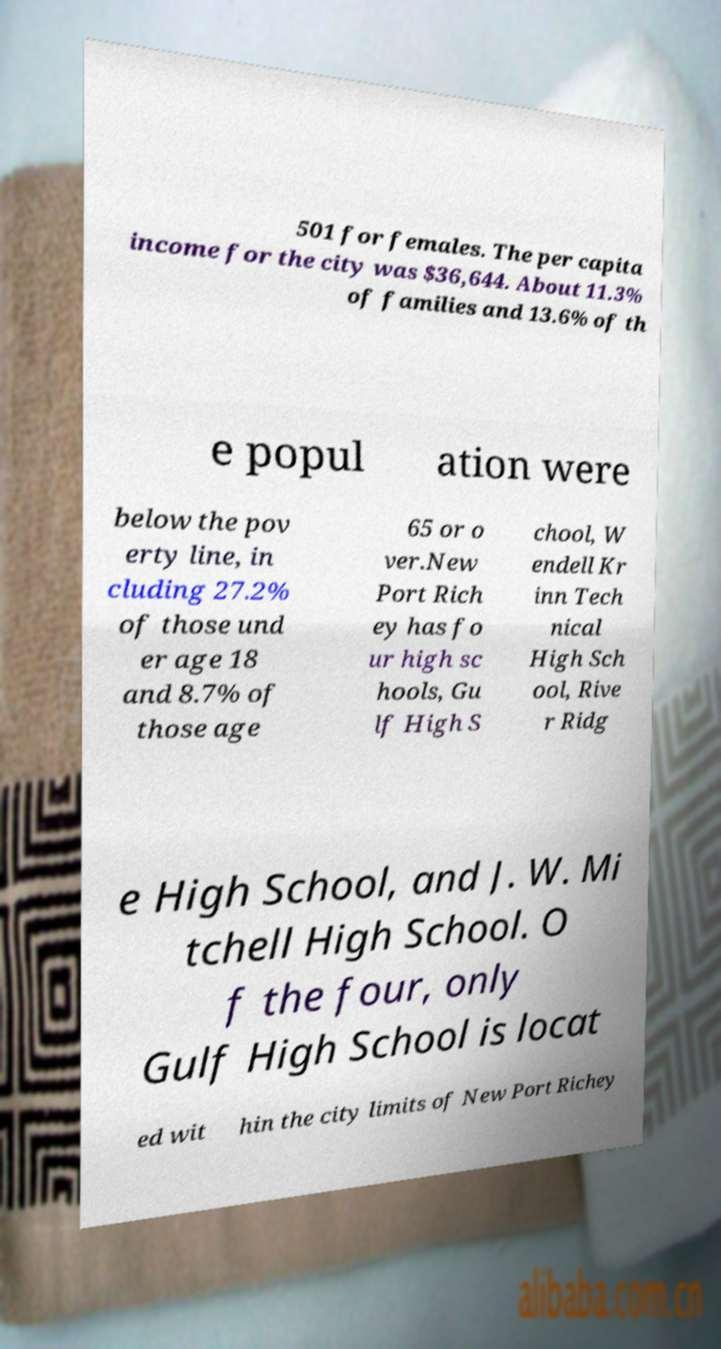There's text embedded in this image that I need extracted. Can you transcribe it verbatim? 501 for females. The per capita income for the city was $36,644. About 11.3% of families and 13.6% of th e popul ation were below the pov erty line, in cluding 27.2% of those und er age 18 and 8.7% of those age 65 or o ver.New Port Rich ey has fo ur high sc hools, Gu lf High S chool, W endell Kr inn Tech nical High Sch ool, Rive r Ridg e High School, and J. W. Mi tchell High School. O f the four, only Gulf High School is locat ed wit hin the city limits of New Port Richey 